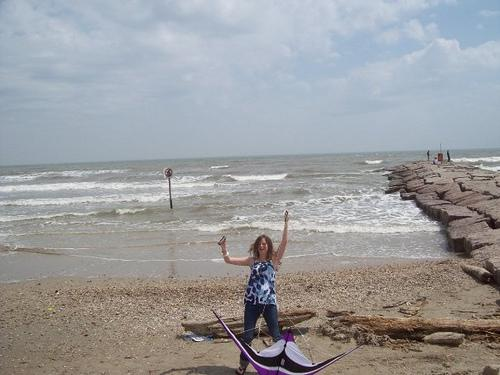What activity is she participating in? Please explain your reasoning. kite flying. She does not have fishing equipment, a frisbee, or a bathing suit. 